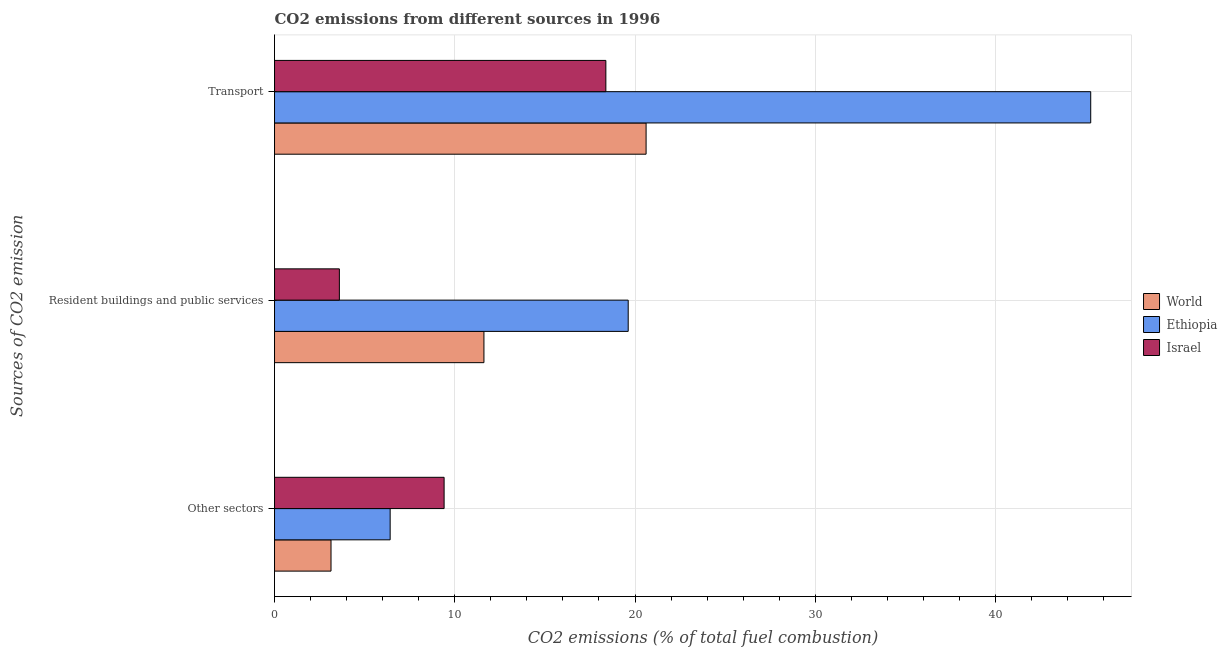How many bars are there on the 2nd tick from the top?
Offer a terse response. 3. How many bars are there on the 3rd tick from the bottom?
Provide a succinct answer. 3. What is the label of the 2nd group of bars from the top?
Provide a succinct answer. Resident buildings and public services. What is the percentage of co2 emissions from transport in Ethiopia?
Make the answer very short. 45.28. Across all countries, what is the maximum percentage of co2 emissions from transport?
Offer a very short reply. 45.28. Across all countries, what is the minimum percentage of co2 emissions from resident buildings and public services?
Ensure brevity in your answer.  3.6. In which country was the percentage of co2 emissions from other sectors maximum?
Keep it short and to the point. Israel. In which country was the percentage of co2 emissions from transport minimum?
Ensure brevity in your answer.  Israel. What is the total percentage of co2 emissions from other sectors in the graph?
Provide a succinct answer. 18.96. What is the difference between the percentage of co2 emissions from other sectors in Israel and that in Ethiopia?
Ensure brevity in your answer.  2.99. What is the difference between the percentage of co2 emissions from transport in Israel and the percentage of co2 emissions from resident buildings and public services in Ethiopia?
Keep it short and to the point. -1.24. What is the average percentage of co2 emissions from resident buildings and public services per country?
Offer a very short reply. 11.61. What is the difference between the percentage of co2 emissions from other sectors and percentage of co2 emissions from resident buildings and public services in World?
Your answer should be compact. -8.48. What is the ratio of the percentage of co2 emissions from transport in World to that in Ethiopia?
Provide a short and direct response. 0.46. Is the percentage of co2 emissions from resident buildings and public services in Ethiopia less than that in World?
Make the answer very short. No. What is the difference between the highest and the second highest percentage of co2 emissions from other sectors?
Provide a short and direct response. 2.99. What is the difference between the highest and the lowest percentage of co2 emissions from transport?
Your response must be concise. 26.9. What does the 2nd bar from the top in Resident buildings and public services represents?
Make the answer very short. Ethiopia. What does the 1st bar from the bottom in Resident buildings and public services represents?
Keep it short and to the point. World. Is it the case that in every country, the sum of the percentage of co2 emissions from other sectors and percentage of co2 emissions from resident buildings and public services is greater than the percentage of co2 emissions from transport?
Offer a terse response. No. How many countries are there in the graph?
Provide a succinct answer. 3. Does the graph contain any zero values?
Offer a very short reply. No. How are the legend labels stacked?
Offer a very short reply. Vertical. What is the title of the graph?
Provide a succinct answer. CO2 emissions from different sources in 1996. Does "Mauritius" appear as one of the legend labels in the graph?
Your response must be concise. No. What is the label or title of the X-axis?
Your answer should be compact. CO2 emissions (% of total fuel combustion). What is the label or title of the Y-axis?
Your answer should be very brief. Sources of CO2 emission. What is the CO2 emissions (% of total fuel combustion) of World in Other sectors?
Make the answer very short. 3.13. What is the CO2 emissions (% of total fuel combustion) in Ethiopia in Other sectors?
Your answer should be compact. 6.42. What is the CO2 emissions (% of total fuel combustion) of Israel in Other sectors?
Give a very brief answer. 9.41. What is the CO2 emissions (% of total fuel combustion) in World in Resident buildings and public services?
Make the answer very short. 11.62. What is the CO2 emissions (% of total fuel combustion) in Ethiopia in Resident buildings and public services?
Provide a short and direct response. 19.62. What is the CO2 emissions (% of total fuel combustion) in Israel in Resident buildings and public services?
Provide a succinct answer. 3.6. What is the CO2 emissions (% of total fuel combustion) in World in Transport?
Offer a very short reply. 20.61. What is the CO2 emissions (% of total fuel combustion) of Ethiopia in Transport?
Make the answer very short. 45.28. What is the CO2 emissions (% of total fuel combustion) in Israel in Transport?
Offer a very short reply. 18.38. Across all Sources of CO2 emission, what is the maximum CO2 emissions (% of total fuel combustion) in World?
Your response must be concise. 20.61. Across all Sources of CO2 emission, what is the maximum CO2 emissions (% of total fuel combustion) in Ethiopia?
Ensure brevity in your answer.  45.28. Across all Sources of CO2 emission, what is the maximum CO2 emissions (% of total fuel combustion) in Israel?
Provide a short and direct response. 18.38. Across all Sources of CO2 emission, what is the minimum CO2 emissions (% of total fuel combustion) of World?
Give a very brief answer. 3.13. Across all Sources of CO2 emission, what is the minimum CO2 emissions (% of total fuel combustion) in Ethiopia?
Provide a succinct answer. 6.42. Across all Sources of CO2 emission, what is the minimum CO2 emissions (% of total fuel combustion) in Israel?
Provide a short and direct response. 3.6. What is the total CO2 emissions (% of total fuel combustion) of World in the graph?
Provide a succinct answer. 35.37. What is the total CO2 emissions (% of total fuel combustion) in Ethiopia in the graph?
Offer a very short reply. 71.32. What is the total CO2 emissions (% of total fuel combustion) in Israel in the graph?
Keep it short and to the point. 31.39. What is the difference between the CO2 emissions (% of total fuel combustion) of World in Other sectors and that in Resident buildings and public services?
Your answer should be compact. -8.48. What is the difference between the CO2 emissions (% of total fuel combustion) of Ethiopia in Other sectors and that in Resident buildings and public services?
Your answer should be compact. -13.21. What is the difference between the CO2 emissions (% of total fuel combustion) in Israel in Other sectors and that in Resident buildings and public services?
Make the answer very short. 5.81. What is the difference between the CO2 emissions (% of total fuel combustion) of World in Other sectors and that in Transport?
Provide a short and direct response. -17.48. What is the difference between the CO2 emissions (% of total fuel combustion) of Ethiopia in Other sectors and that in Transport?
Your answer should be compact. -38.87. What is the difference between the CO2 emissions (% of total fuel combustion) in Israel in Other sectors and that in Transport?
Keep it short and to the point. -8.97. What is the difference between the CO2 emissions (% of total fuel combustion) of World in Resident buildings and public services and that in Transport?
Your answer should be very brief. -9. What is the difference between the CO2 emissions (% of total fuel combustion) of Ethiopia in Resident buildings and public services and that in Transport?
Provide a short and direct response. -25.66. What is the difference between the CO2 emissions (% of total fuel combustion) in Israel in Resident buildings and public services and that in Transport?
Provide a short and direct response. -14.78. What is the difference between the CO2 emissions (% of total fuel combustion) of World in Other sectors and the CO2 emissions (% of total fuel combustion) of Ethiopia in Resident buildings and public services?
Keep it short and to the point. -16.49. What is the difference between the CO2 emissions (% of total fuel combustion) of World in Other sectors and the CO2 emissions (% of total fuel combustion) of Israel in Resident buildings and public services?
Offer a very short reply. -0.46. What is the difference between the CO2 emissions (% of total fuel combustion) of Ethiopia in Other sectors and the CO2 emissions (% of total fuel combustion) of Israel in Resident buildings and public services?
Provide a short and direct response. 2.82. What is the difference between the CO2 emissions (% of total fuel combustion) in World in Other sectors and the CO2 emissions (% of total fuel combustion) in Ethiopia in Transport?
Your answer should be compact. -42.15. What is the difference between the CO2 emissions (% of total fuel combustion) in World in Other sectors and the CO2 emissions (% of total fuel combustion) in Israel in Transport?
Your answer should be very brief. -15.25. What is the difference between the CO2 emissions (% of total fuel combustion) of Ethiopia in Other sectors and the CO2 emissions (% of total fuel combustion) of Israel in Transport?
Offer a very short reply. -11.97. What is the difference between the CO2 emissions (% of total fuel combustion) of World in Resident buildings and public services and the CO2 emissions (% of total fuel combustion) of Ethiopia in Transport?
Provide a succinct answer. -33.67. What is the difference between the CO2 emissions (% of total fuel combustion) of World in Resident buildings and public services and the CO2 emissions (% of total fuel combustion) of Israel in Transport?
Keep it short and to the point. -6.76. What is the difference between the CO2 emissions (% of total fuel combustion) of Ethiopia in Resident buildings and public services and the CO2 emissions (% of total fuel combustion) of Israel in Transport?
Your answer should be compact. 1.24. What is the average CO2 emissions (% of total fuel combustion) of World per Sources of CO2 emission?
Offer a very short reply. 11.79. What is the average CO2 emissions (% of total fuel combustion) in Ethiopia per Sources of CO2 emission?
Keep it short and to the point. 23.77. What is the average CO2 emissions (% of total fuel combustion) in Israel per Sources of CO2 emission?
Keep it short and to the point. 10.46. What is the difference between the CO2 emissions (% of total fuel combustion) in World and CO2 emissions (% of total fuel combustion) in Ethiopia in Other sectors?
Your answer should be compact. -3.28. What is the difference between the CO2 emissions (% of total fuel combustion) of World and CO2 emissions (% of total fuel combustion) of Israel in Other sectors?
Offer a very short reply. -6.28. What is the difference between the CO2 emissions (% of total fuel combustion) in Ethiopia and CO2 emissions (% of total fuel combustion) in Israel in Other sectors?
Keep it short and to the point. -2.99. What is the difference between the CO2 emissions (% of total fuel combustion) in World and CO2 emissions (% of total fuel combustion) in Ethiopia in Resident buildings and public services?
Offer a terse response. -8. What is the difference between the CO2 emissions (% of total fuel combustion) of World and CO2 emissions (% of total fuel combustion) of Israel in Resident buildings and public services?
Your answer should be very brief. 8.02. What is the difference between the CO2 emissions (% of total fuel combustion) of Ethiopia and CO2 emissions (% of total fuel combustion) of Israel in Resident buildings and public services?
Ensure brevity in your answer.  16.02. What is the difference between the CO2 emissions (% of total fuel combustion) of World and CO2 emissions (% of total fuel combustion) of Ethiopia in Transport?
Your response must be concise. -24.67. What is the difference between the CO2 emissions (% of total fuel combustion) in World and CO2 emissions (% of total fuel combustion) in Israel in Transport?
Your answer should be compact. 2.23. What is the difference between the CO2 emissions (% of total fuel combustion) in Ethiopia and CO2 emissions (% of total fuel combustion) in Israel in Transport?
Offer a very short reply. 26.9. What is the ratio of the CO2 emissions (% of total fuel combustion) in World in Other sectors to that in Resident buildings and public services?
Give a very brief answer. 0.27. What is the ratio of the CO2 emissions (% of total fuel combustion) in Ethiopia in Other sectors to that in Resident buildings and public services?
Your answer should be compact. 0.33. What is the ratio of the CO2 emissions (% of total fuel combustion) in Israel in Other sectors to that in Resident buildings and public services?
Offer a terse response. 2.61. What is the ratio of the CO2 emissions (% of total fuel combustion) in World in Other sectors to that in Transport?
Offer a terse response. 0.15. What is the ratio of the CO2 emissions (% of total fuel combustion) in Ethiopia in Other sectors to that in Transport?
Ensure brevity in your answer.  0.14. What is the ratio of the CO2 emissions (% of total fuel combustion) in Israel in Other sectors to that in Transport?
Provide a succinct answer. 0.51. What is the ratio of the CO2 emissions (% of total fuel combustion) of World in Resident buildings and public services to that in Transport?
Provide a short and direct response. 0.56. What is the ratio of the CO2 emissions (% of total fuel combustion) in Ethiopia in Resident buildings and public services to that in Transport?
Provide a succinct answer. 0.43. What is the ratio of the CO2 emissions (% of total fuel combustion) of Israel in Resident buildings and public services to that in Transport?
Ensure brevity in your answer.  0.2. What is the difference between the highest and the second highest CO2 emissions (% of total fuel combustion) in World?
Your answer should be very brief. 9. What is the difference between the highest and the second highest CO2 emissions (% of total fuel combustion) in Ethiopia?
Provide a short and direct response. 25.66. What is the difference between the highest and the second highest CO2 emissions (% of total fuel combustion) of Israel?
Offer a very short reply. 8.97. What is the difference between the highest and the lowest CO2 emissions (% of total fuel combustion) of World?
Provide a short and direct response. 17.48. What is the difference between the highest and the lowest CO2 emissions (% of total fuel combustion) in Ethiopia?
Your answer should be compact. 38.87. What is the difference between the highest and the lowest CO2 emissions (% of total fuel combustion) in Israel?
Provide a succinct answer. 14.78. 